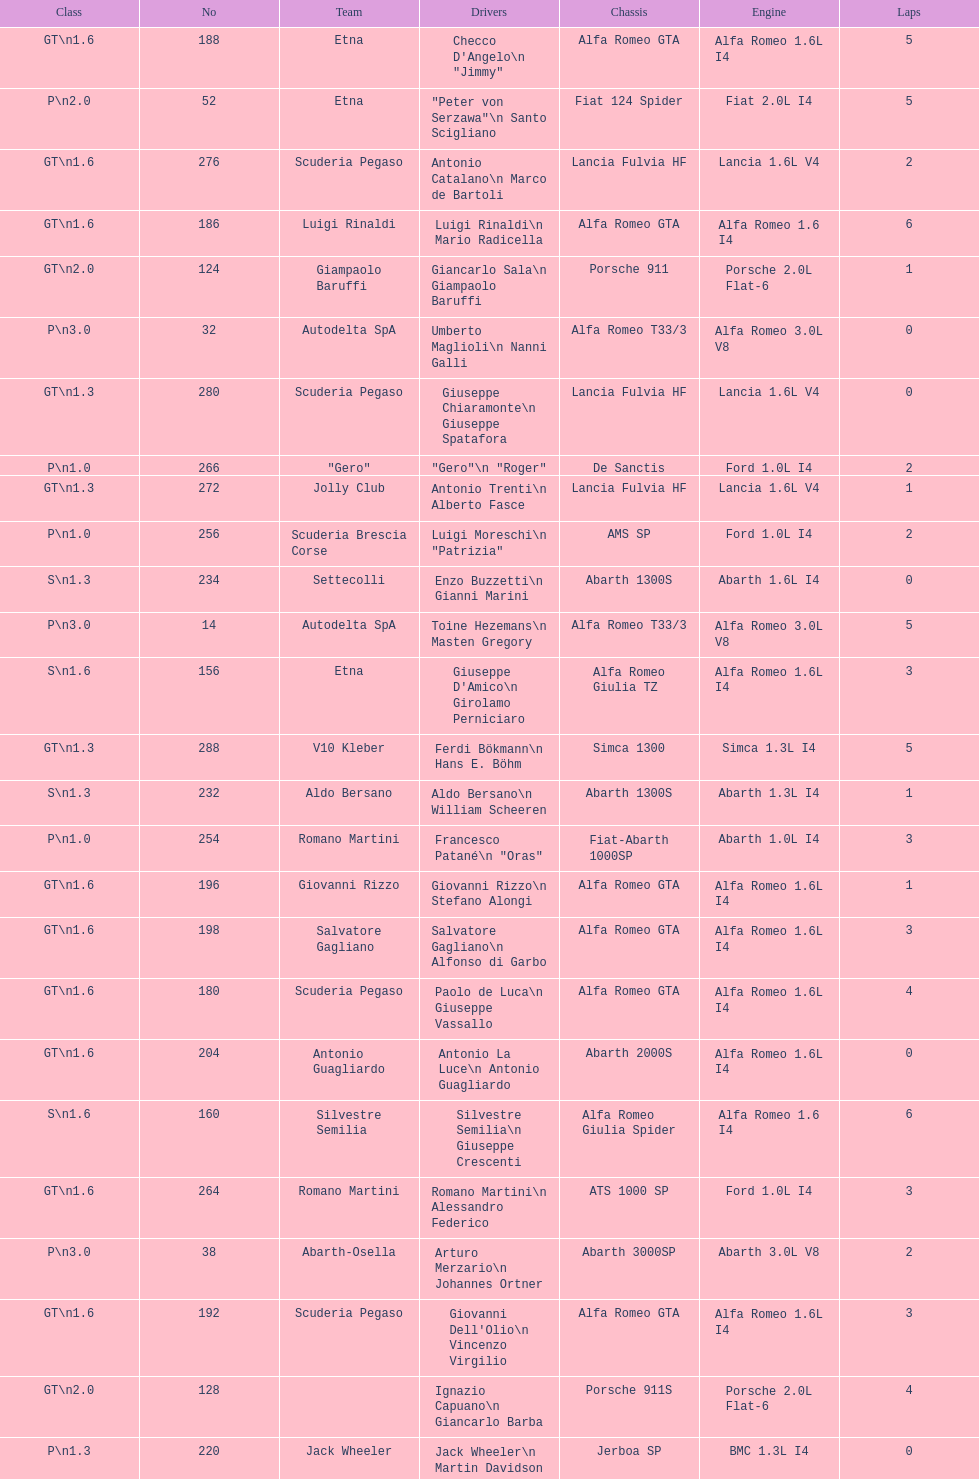How many drivers are from italy? 48. 